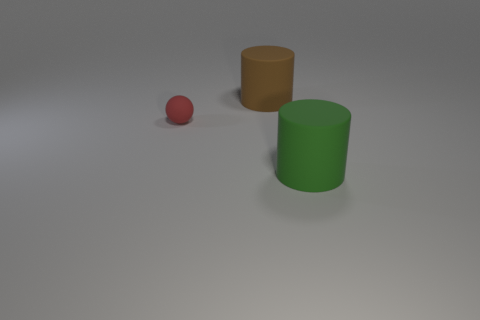Add 1 green rubber cylinders. How many objects exist? 4 Subtract all spheres. How many objects are left? 2 Add 2 big objects. How many big objects exist? 4 Subtract 0 red blocks. How many objects are left? 3 Subtract all cyan balls. Subtract all big brown cylinders. How many objects are left? 2 Add 3 brown matte things. How many brown matte things are left? 4 